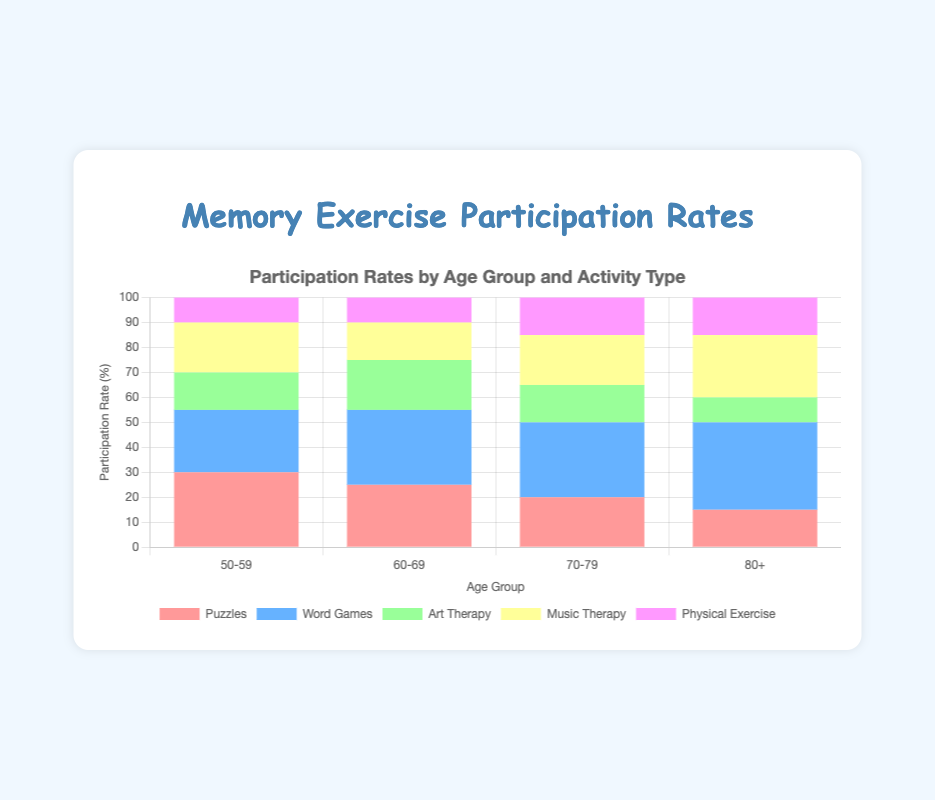What age group has the highest participation rate in Word Games? By analyzing the chart, we see the percentage of each age group’s participation in Word Games. The age group 80+ has the highest rate at 35%.
Answer: 80+ Which activity has the highest participation rate for individuals aged 70-79? From the chart, the highest bar segment for the age group 70-79 is for Word Games, at 30%.
Answer: Word Games Calculate the total participation rate for the age group 60-69. Sum the participation rates for Puzzles (25%), Word Games (30%), Art Therapy (20%), Music Therapy (15%), and Physical Exercise (10%). The total is 25 + 30 + 20 + 15 + 10 = 100%.
Answer: 100% Compare the participation rate in Music Therapy between the 50-59 and 80+ age groups. Which has a higher rate and by how much? The participation rate in Music Therapy for the 50-59 age group is 20% and for the 80+ age group is 25%. The 80+ age group’s rate is higher by 5%.
Answer: 80+ by 5% What is the average participation rate in Art Therapy across all age groups? Sum the participation rates for Art Therapy: 15% (50-59), 20% (60-69), 15% (70-79), 10% (80+). The total is 15 + 20 + 15 + 10 = 60%. With 4 age groups, the average is 60%/4 = 15%.
Answer: 15% Which age group has the lowest participation in Puzzles? The bar segment representing Puzzles is lowest for the 80+ age group at 15%.
Answer: 80+ What is the difference in participation rate in Physical Exercise between the 60-69 and 70-79 age groups? Both age groups 60-69 and 70-79 have the same participation rate in Physical Exercise, which is 10% for the 60-69 and 15% for the 70-79, resulting in a 5% difference.
Answer: 5% Among the 70-79 age group, which activity has the smallest participation rate? The shortest bar segment for the 70-79 age group is for Art Therapy, at 15%.
Answer: Art Therapy What’s the total participation rate in Puzzles across all age groups? Sum of Puzzles participation rates: 30% (50-59), 25% (60-69), 20% (70-79), 15% (80+). Therefore, total participation is 30 + 25 + 20 + 15 = 90%.
Answer: 90% Among the 80+ age group, which activity has the second-highest participation rate? By looking at the segments of the age group 80+, the second-highest bar is for Music Therapy at 25%.
Answer: Music Therapy 